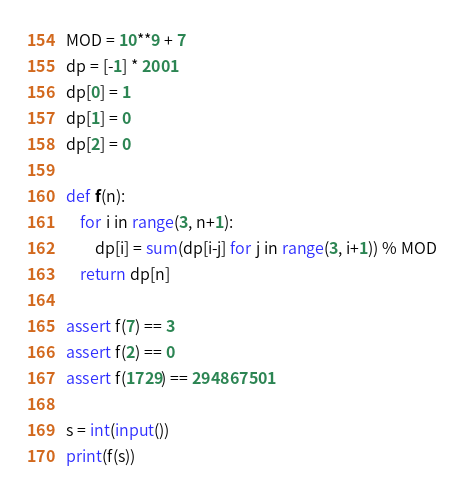Convert code to text. <code><loc_0><loc_0><loc_500><loc_500><_Python_>MOD = 10**9 + 7
dp = [-1] * 2001
dp[0] = 1
dp[1] = 0
dp[2] = 0

def f(n):
    for i in range(3, n+1):
        dp[i] = sum(dp[i-j] for j in range(3, i+1)) % MOD
    return dp[n]

assert f(7) == 3
assert f(2) == 0
assert f(1729) == 294867501

s = int(input())
print(f(s))</code> 